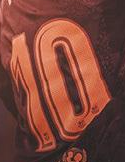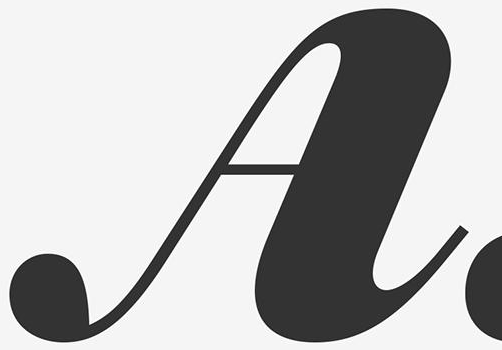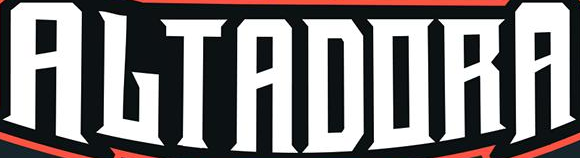Transcribe the words shown in these images in order, separated by a semicolon. 10; A; ALTADORA 